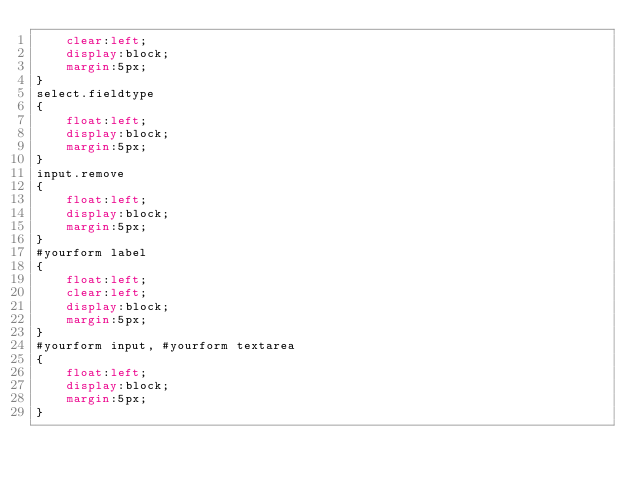<code> <loc_0><loc_0><loc_500><loc_500><_CSS_>    clear:left;
    display:block;
    margin:5px;
}
select.fieldtype
{
    float:left;
    display:block;
    margin:5px;
}
input.remove
{
    float:left;
    display:block;
    margin:5px;
}
#yourform label
{
    float:left;
    clear:left;
    display:block;
    margin:5px;
}
#yourform input, #yourform textarea
{
    float:left;
    display:block;
    margin:5px;
}
</code> 